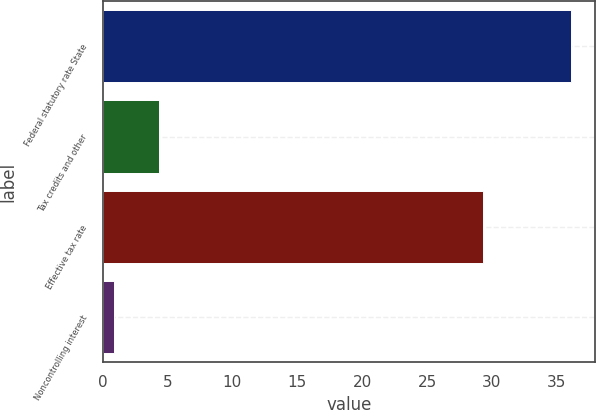Convert chart. <chart><loc_0><loc_0><loc_500><loc_500><bar_chart><fcel>Federal statutory rate State<fcel>Tax credits and other<fcel>Effective tax rate<fcel>Noncontrolling interest<nl><fcel>36.12<fcel>4.31<fcel>29.3<fcel>0.9<nl></chart> 